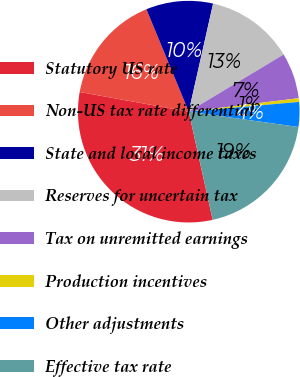Convert chart to OTSL. <chart><loc_0><loc_0><loc_500><loc_500><pie_chart><fcel>Statutory US rate<fcel>Non-US tax rate differential<fcel>State and local income taxes<fcel>Reserves for uncertain tax<fcel>Tax on unremitted earnings<fcel>Production incentives<fcel>Other adjustments<fcel>Effective tax rate<nl><fcel>31.31%<fcel>15.92%<fcel>9.77%<fcel>12.84%<fcel>6.69%<fcel>0.54%<fcel>3.61%<fcel>19.32%<nl></chart> 